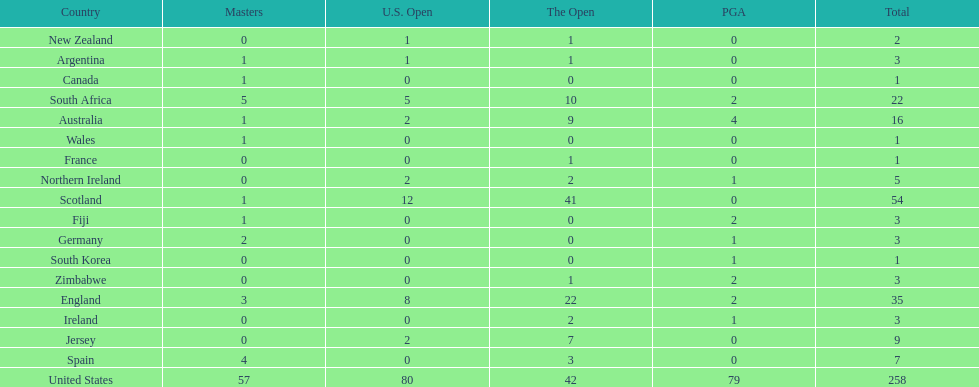How many total championships does spain have? 7. 